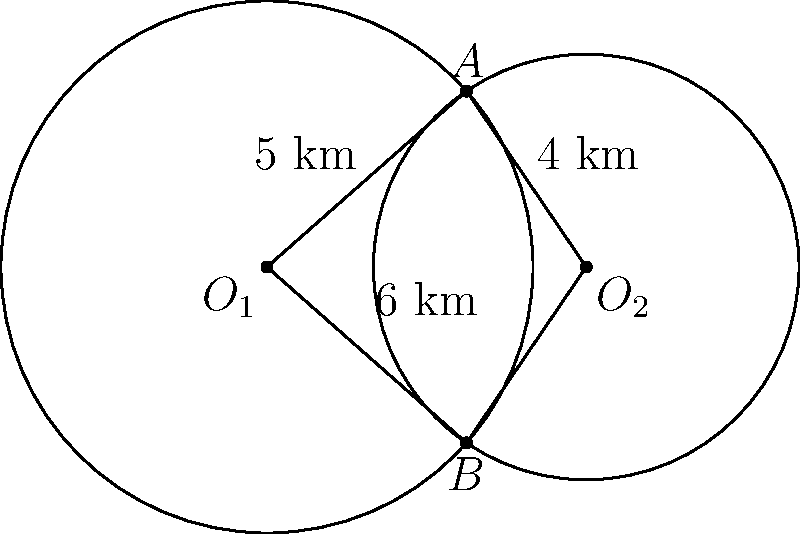Two solar energy coverage zones are represented by overlapping circles with centers $O_1$ and $O_2$. The radius of the first circle is 5 km, and the radius of the second circle is 4 km. The distance between the centers is 6 km. Calculate the area of the region covered by both solar energy zones (the overlapping area). To find the area of overlap between two circles, we can use the following steps:

1) First, we need to find the angle $\theta$ at the center of each circle formed by the radii to the intersection points. We can do this using the cosine law:

   For circle 1: $\cos(\theta_1/2) = \frac{5^2 + 6^2 - 4^2}{2 \cdot 5 \cdot 6} = \frac{37}{60}$
   For circle 2: $\cos(\theta_2/2) = \frac{4^2 + 6^2 - 5^2}{2 \cdot 4 \cdot 6} = \frac{11}{16}$

2) Calculate $\theta_1$ and $\theta_2$:
   $\theta_1 = 2 \arccos(\frac{37}{60}) \approx 1.8545$ radians
   $\theta_2 = 2 \arccos(\frac{11}{16}) \approx 2.0944$ radians

3) The area of overlap is the sum of two sectors minus the area of the rhombus formed by the radii:

   Area = $\frac{1}{2}r_1^2\theta_1 + \frac{1}{2}r_2^2\theta_2 - \frac{1}{2}(6 \cdot 6 \sin(\frac{\theta_1}{2}))$

4) Substituting the values:
   Area = $\frac{1}{2}(5^2 \cdot 1.8545 + 4^2 \cdot 2.0944) - \frac{1}{2}(36 \sin(0.9272))$
        $\approx 23.1813 + 16.7552 - 16.6184$
        $\approx 23.3181$ km²

Therefore, the area of overlap is approximately 23.32 km².
Answer: 23.32 km² 